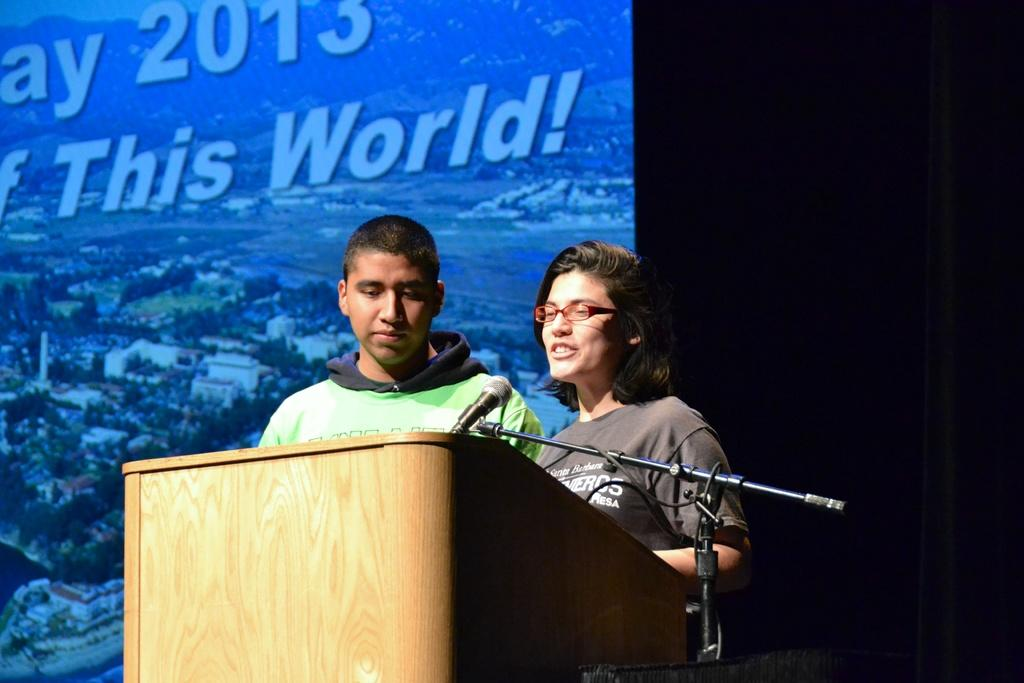How many people are present in the image? There are two people standing in front of the dais. What can be seen beside the dais? There is a microphone beside the dais. What is visible in the background of the image? There is a screen in the background of the image. What type of smell can be detected in the image? There is no information about any smell in the image, as it only provides visual details. 